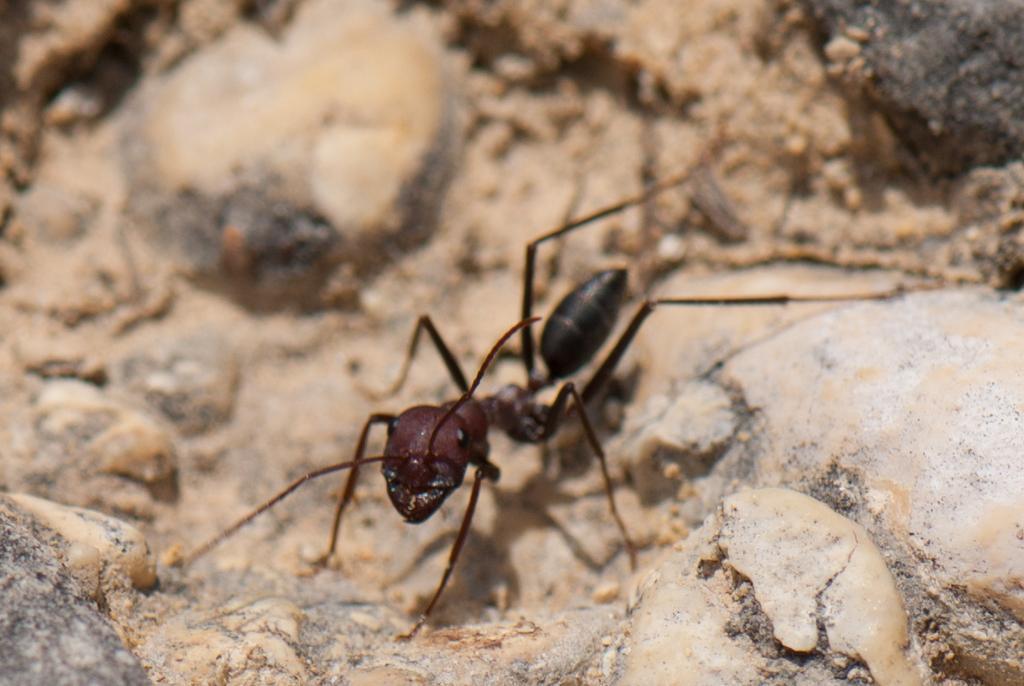Can you describe this image briefly? In this image I can see an ant which is brown and black in color on the brown colored rocky surface. 